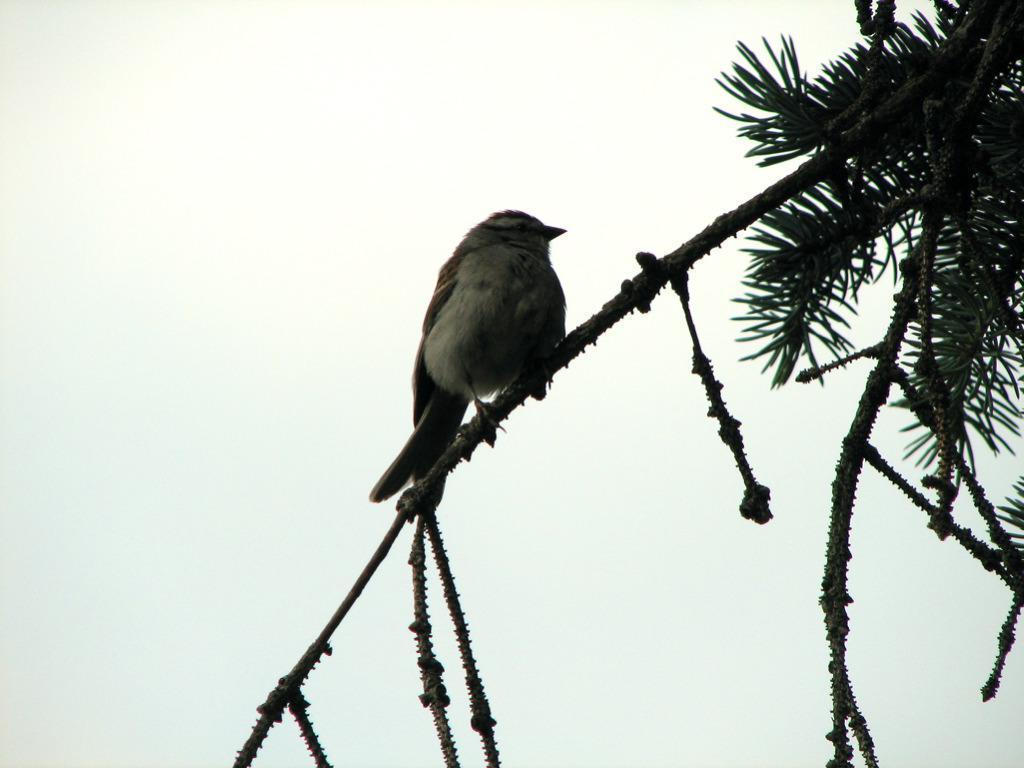Could you give a brief overview of what you see in this image? In this image in front there is a bird on the branch of a tree. In the background of the image there is sky. 